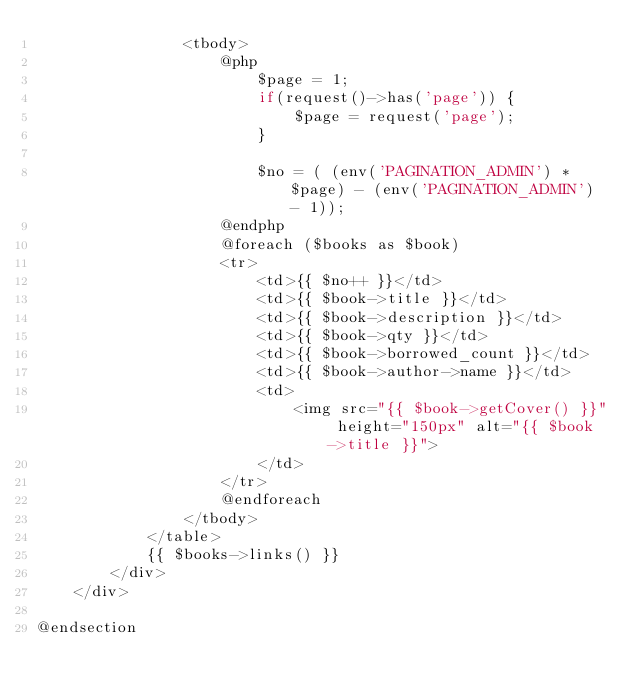<code> <loc_0><loc_0><loc_500><loc_500><_PHP_>                <tbody>
                    @php
                        $page = 1;
                        if(request()->has('page')) {
                            $page = request('page');
                        }

                        $no = ( (env('PAGINATION_ADMIN') * $page) - (env('PAGINATION_ADMIN') - 1));
                    @endphp
                    @foreach ($books as $book)
                    <tr>
                        <td>{{ $no++ }}</td>
                        <td>{{ $book->title }}</td>
                        <td>{{ $book->description }}</td>
                        <td>{{ $book->qty }}</td>
                        <td>{{ $book->borrowed_count }}</td>
                        <td>{{ $book->author->name }}</td>
                        <td>
                            <img src="{{ $book->getCover() }}" height="150px" alt="{{ $book->title }}">
                        </td>
                    </tr>
                    @endforeach
                </tbody>
            </table>
            {{ $books->links() }}
        </div>
    </div>

@endsection
</code> 